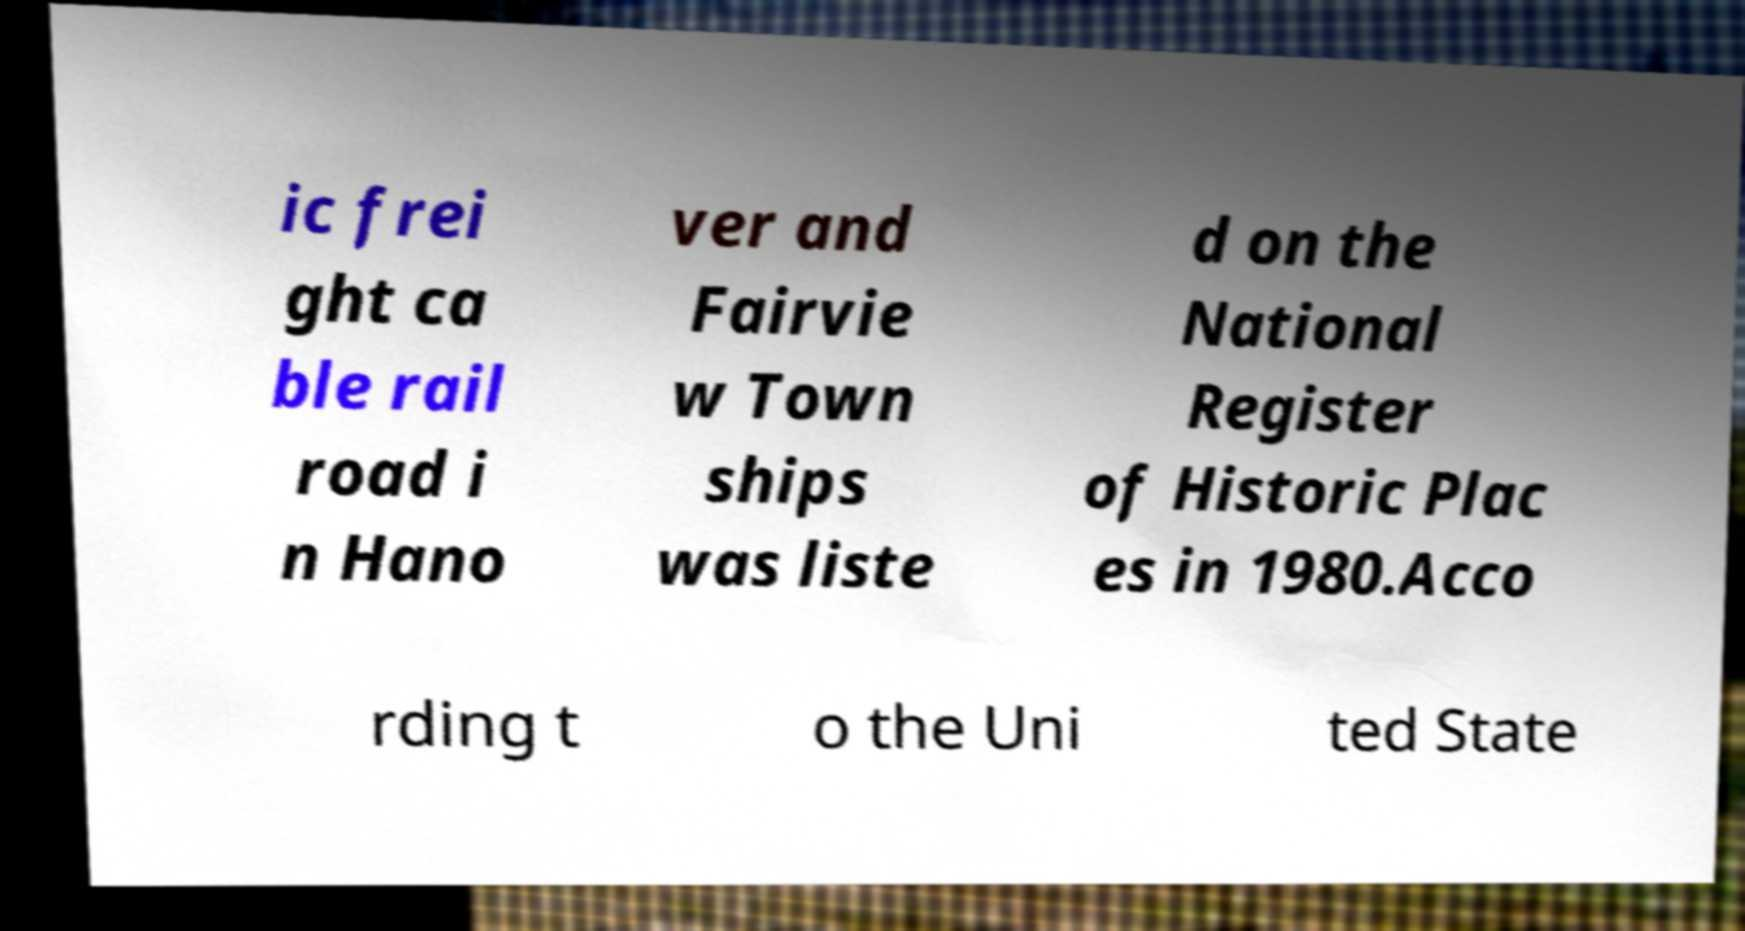Could you assist in decoding the text presented in this image and type it out clearly? ic frei ght ca ble rail road i n Hano ver and Fairvie w Town ships was liste d on the National Register of Historic Plac es in 1980.Acco rding t o the Uni ted State 